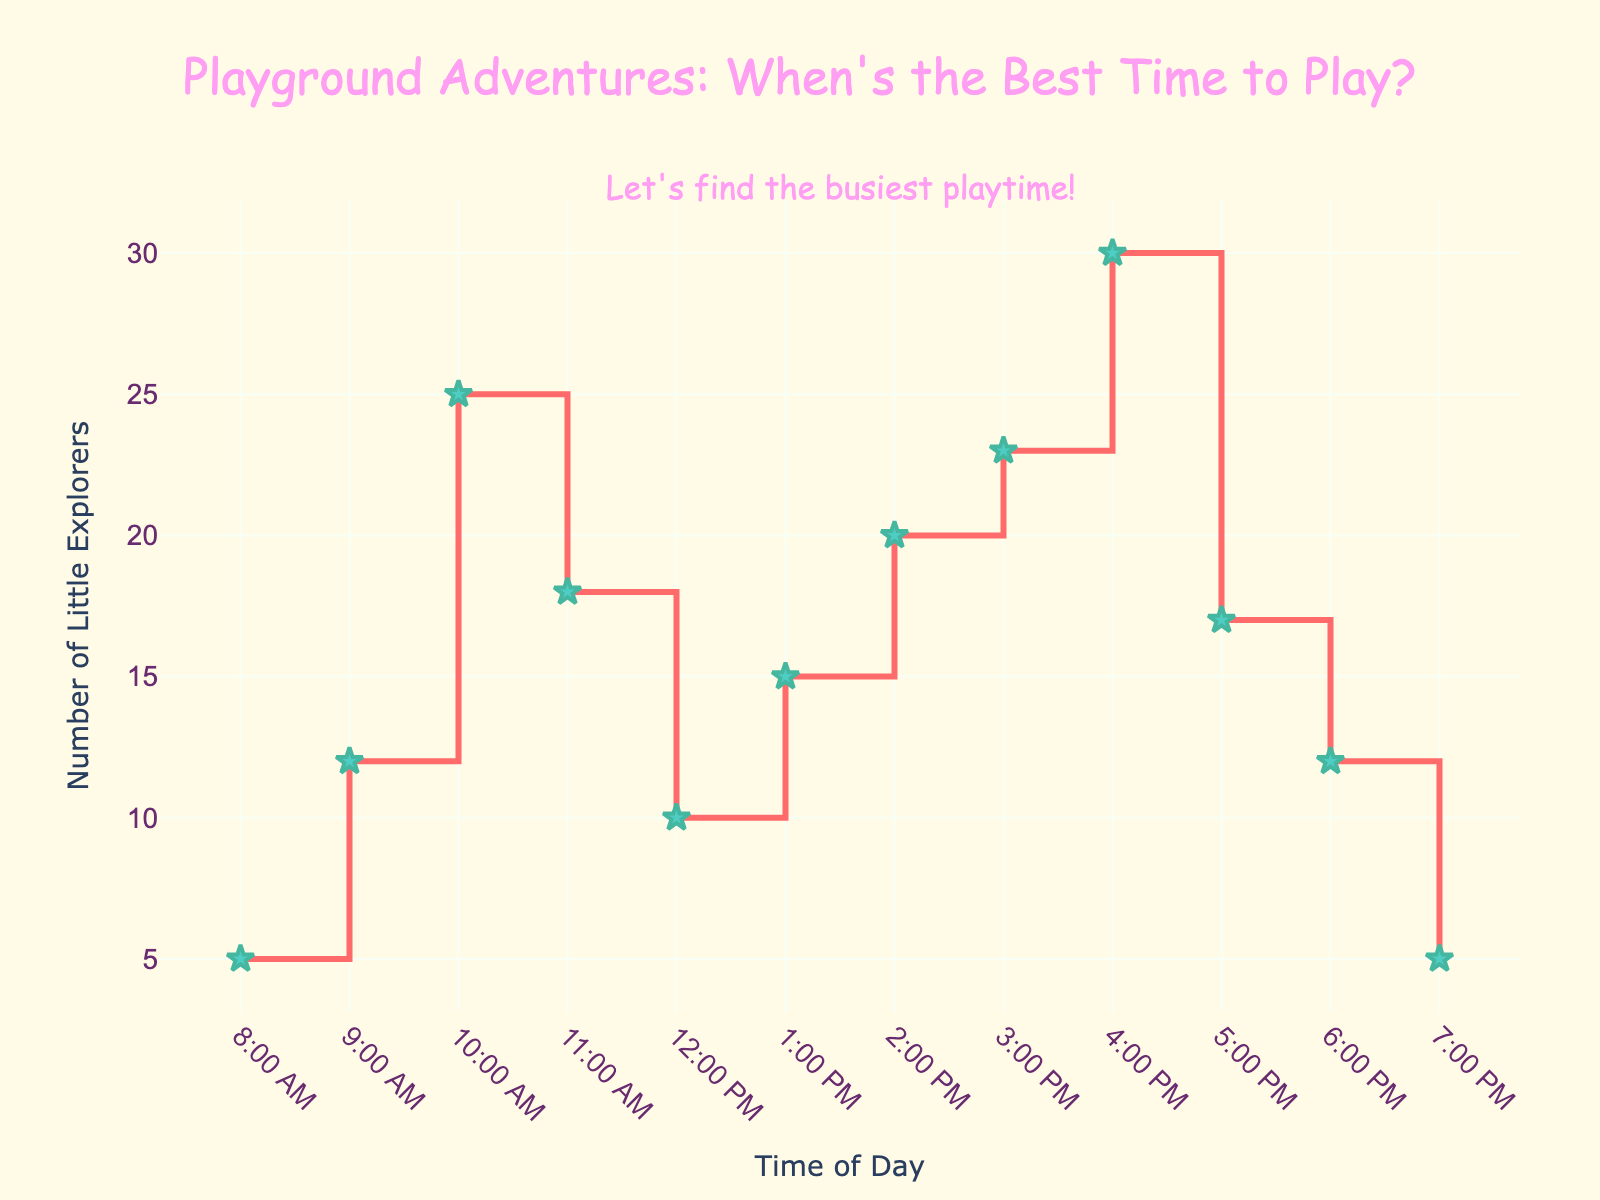What is the title of the plot? The title is located at the top of the plot and describes the content it represents.
Answer: Playground Adventures: When's the Best Time to Play? How many times did kids visit the playground at 11:00 AM? To determine this, locate the time "11:00 AM" on the x-axis and then trace vertically to find the corresponding value on the y-axis, which represents the visit count.
Answer: 18 What time had the highest number of little explorers visiting the playground? Find the peak or highest point on the plotted line and match it to the x-axis to get the corresponding time of day.
Answer: 4:00 PM During which two consecutive hours did the number of visits decrease the most? Compare the differences between the visit counts for each consecutive hour and identify the pair with the largest decrease.
Answer: 10:00 AM to 11:00 AM What is the total number of visits from 9:00 AM to 11:00 AM? Sum the visit counts for each hour from 9:00 AM to 11:00 AM: (12 + 25 + 18) = 55
Answer: 55 How does the number of visits at 1:00 PM compare to 6:00 PM? Check the y-values for 1:00 PM and 6:00 PM and compare them.
Answer: 1:00 PM has more visits than 6:00 PM What's the average number of playground visitors between 3:00 PM and 5:00 PM? Sum the visit counts at 3:00 PM, 4:00 PM, and 5:00 PM, then divide by the number of hours: (23 + 30 + 17) / 3 = 23.33
Answer: 23.33 How many times did fewer than 10 kids visit the playground? Count the data points where the visit count is less than 10.
Answer: 2 (8:00 AM and 7:00 PM) Which time slot had an equal number of visits as 6:00 PM? Look for another data point that has the same visit count as 6:00 PM (12 visits).
Answer: 9:00 AM 